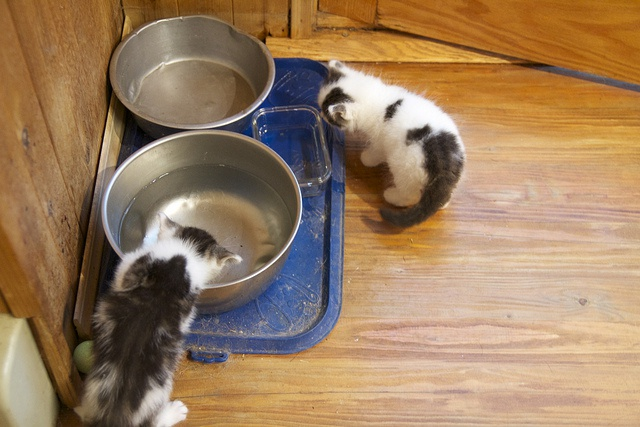Describe the objects in this image and their specific colors. I can see bowl in brown, gray, and black tones, cat in brown, black, gray, lightgray, and darkgray tones, bowl in brown, gray, and darkgray tones, cat in brown, white, black, gray, and tan tones, and sports ball in brown, darkgreen, black, and olive tones in this image. 